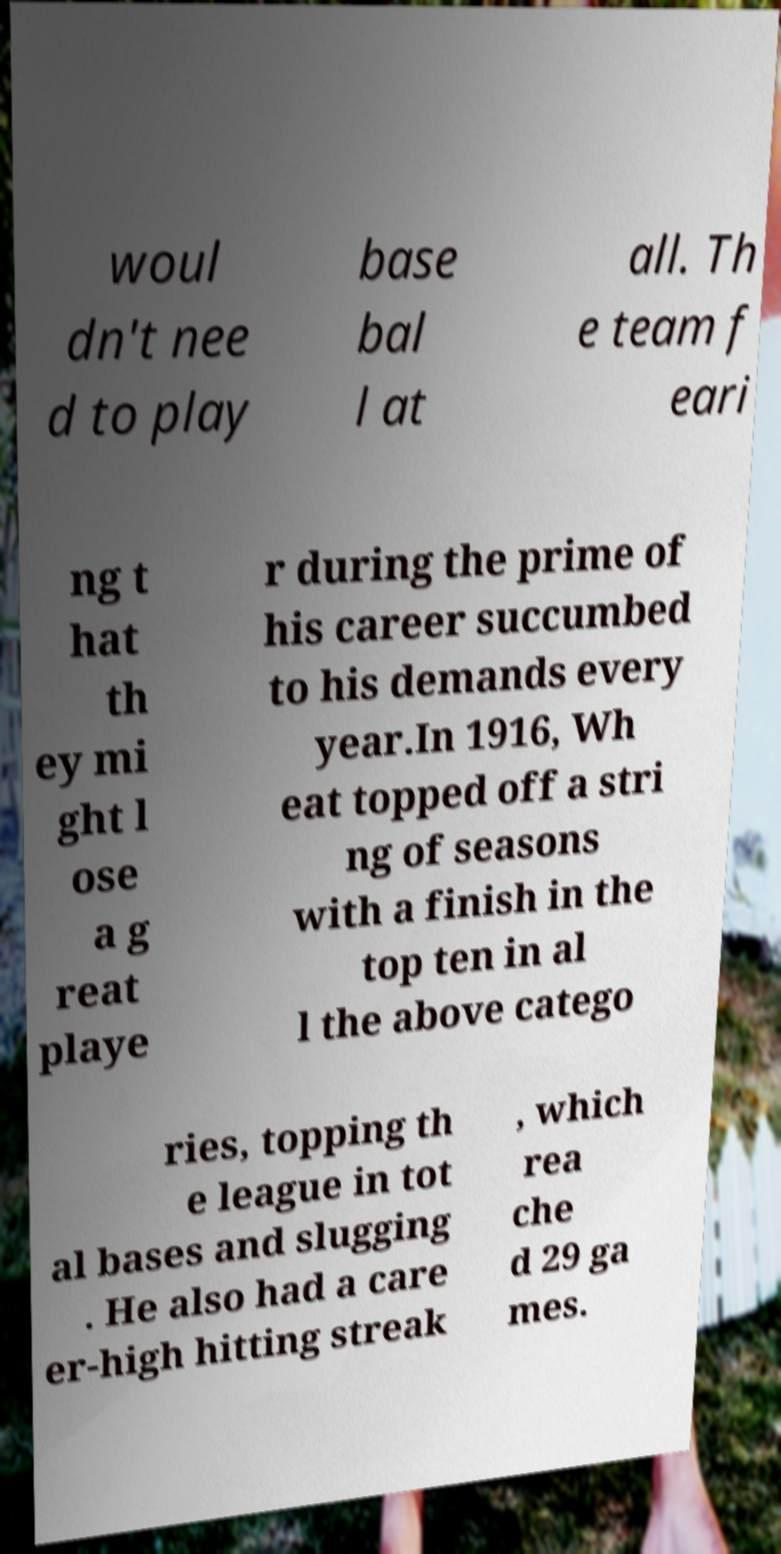Please read and relay the text visible in this image. What does it say? woul dn't nee d to play base bal l at all. Th e team f eari ng t hat th ey mi ght l ose a g reat playe r during the prime of his career succumbed to his demands every year.In 1916, Wh eat topped off a stri ng of seasons with a finish in the top ten in al l the above catego ries, topping th e league in tot al bases and slugging . He also had a care er-high hitting streak , which rea che d 29 ga mes. 